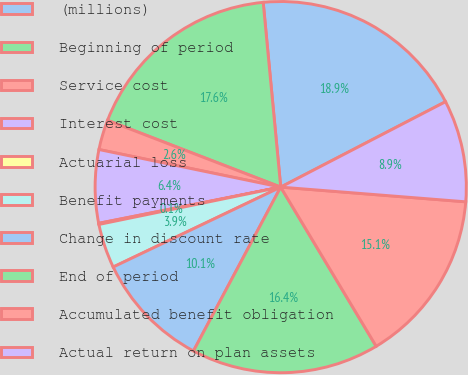Convert chart. <chart><loc_0><loc_0><loc_500><loc_500><pie_chart><fcel>(millions)<fcel>Beginning of period<fcel>Service cost<fcel>Interest cost<fcel>Actuarial loss<fcel>Benefit payments<fcel>Change in discount rate<fcel>End of period<fcel>Accumulated benefit obligation<fcel>Actual return on plan assets<nl><fcel>18.9%<fcel>17.64%<fcel>2.61%<fcel>6.37%<fcel>0.1%<fcel>3.86%<fcel>10.13%<fcel>16.39%<fcel>15.14%<fcel>8.87%<nl></chart> 